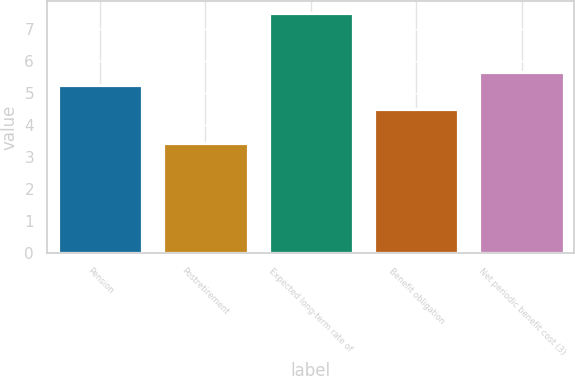Convert chart. <chart><loc_0><loc_0><loc_500><loc_500><bar_chart><fcel>Pension<fcel>Postretirement<fcel>Expected long-term rate of<fcel>Benefit obligation<fcel>Net periodic benefit cost (3)<nl><fcel>5.25<fcel>3.45<fcel>7.5<fcel>4.5<fcel>5.66<nl></chart> 